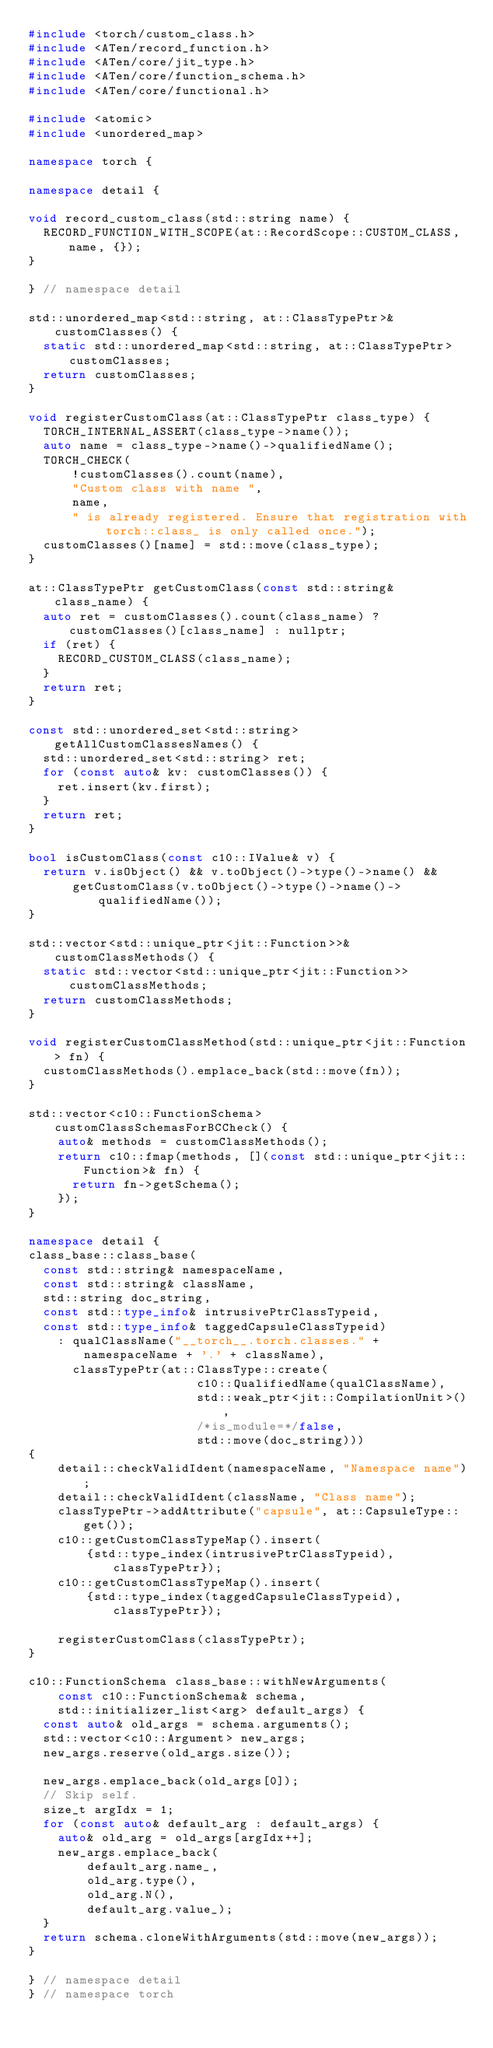Convert code to text. <code><loc_0><loc_0><loc_500><loc_500><_C++_>#include <torch/custom_class.h>
#include <ATen/record_function.h>
#include <ATen/core/jit_type.h>
#include <ATen/core/function_schema.h>
#include <ATen/core/functional.h>

#include <atomic>
#include <unordered_map>

namespace torch {

namespace detail {

void record_custom_class(std::string name) {
  RECORD_FUNCTION_WITH_SCOPE(at::RecordScope::CUSTOM_CLASS, name, {});
}

} // namespace detail

std::unordered_map<std::string, at::ClassTypePtr>& customClasses() {
  static std::unordered_map<std::string, at::ClassTypePtr> customClasses;
  return customClasses;
}

void registerCustomClass(at::ClassTypePtr class_type) {
  TORCH_INTERNAL_ASSERT(class_type->name());
  auto name = class_type->name()->qualifiedName();
  TORCH_CHECK(
      !customClasses().count(name),
      "Custom class with name ",
      name,
      " is already registered. Ensure that registration with torch::class_ is only called once.");
  customClasses()[name] = std::move(class_type);
}

at::ClassTypePtr getCustomClass(const std::string& class_name) {
  auto ret = customClasses().count(class_name) ? customClasses()[class_name] : nullptr;
  if (ret) {
    RECORD_CUSTOM_CLASS(class_name);
  }
  return ret;
}

const std::unordered_set<std::string> getAllCustomClassesNames() {
  std::unordered_set<std::string> ret;
  for (const auto& kv: customClasses()) {
    ret.insert(kv.first);
  }
  return ret;
}

bool isCustomClass(const c10::IValue& v) {
  return v.isObject() && v.toObject()->type()->name() &&
      getCustomClass(v.toObject()->type()->name()->qualifiedName());
}

std::vector<std::unique_ptr<jit::Function>>& customClassMethods() {
  static std::vector<std::unique_ptr<jit::Function>> customClassMethods;
  return customClassMethods;
}

void registerCustomClassMethod(std::unique_ptr<jit::Function> fn) {
  customClassMethods().emplace_back(std::move(fn));
}

std::vector<c10::FunctionSchema> customClassSchemasForBCCheck() {
    auto& methods = customClassMethods();
    return c10::fmap(methods, [](const std::unique_ptr<jit::Function>& fn) {
      return fn->getSchema();
    });
}

namespace detail {
class_base::class_base(
  const std::string& namespaceName,
  const std::string& className,
  std::string doc_string,
  const std::type_info& intrusivePtrClassTypeid,
  const std::type_info& taggedCapsuleClassTypeid)
    : qualClassName("__torch__.torch.classes." + namespaceName + '.' + className),
      classTypePtr(at::ClassType::create(
                       c10::QualifiedName(qualClassName),
                       std::weak_ptr<jit::CompilationUnit>(),
                       /*is_module=*/false,
                       std::move(doc_string)))
{
    detail::checkValidIdent(namespaceName, "Namespace name");
    detail::checkValidIdent(className, "Class name");
    classTypePtr->addAttribute("capsule", at::CapsuleType::get());
    c10::getCustomClassTypeMap().insert(
        {std::type_index(intrusivePtrClassTypeid), classTypePtr});
    c10::getCustomClassTypeMap().insert(
        {std::type_index(taggedCapsuleClassTypeid), classTypePtr});

    registerCustomClass(classTypePtr);
}

c10::FunctionSchema class_base::withNewArguments(
    const c10::FunctionSchema& schema,
    std::initializer_list<arg> default_args) {
  const auto& old_args = schema.arguments();
  std::vector<c10::Argument> new_args;
  new_args.reserve(old_args.size());

  new_args.emplace_back(old_args[0]);
  // Skip self.
  size_t argIdx = 1;
  for (const auto& default_arg : default_args) {
    auto& old_arg = old_args[argIdx++];
    new_args.emplace_back(
        default_arg.name_,
        old_arg.type(),
        old_arg.N(),
        default_arg.value_);
  }
  return schema.cloneWithArguments(std::move(new_args));
}

} // namespace detail
} // namespace torch
</code> 